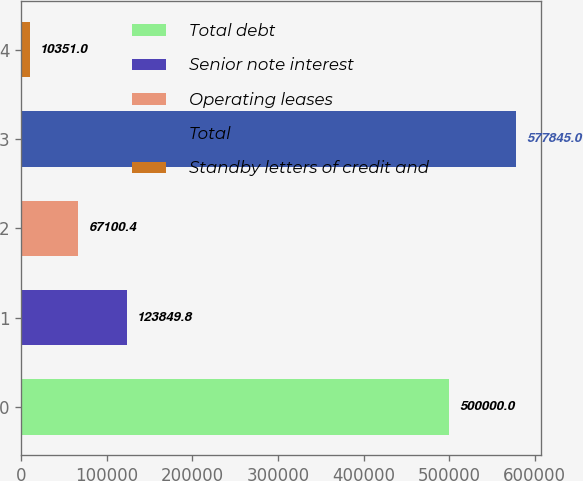<chart> <loc_0><loc_0><loc_500><loc_500><bar_chart><fcel>Total debt<fcel>Senior note interest<fcel>Operating leases<fcel>Total<fcel>Standby letters of credit and<nl><fcel>500000<fcel>123850<fcel>67100.4<fcel>577845<fcel>10351<nl></chart> 